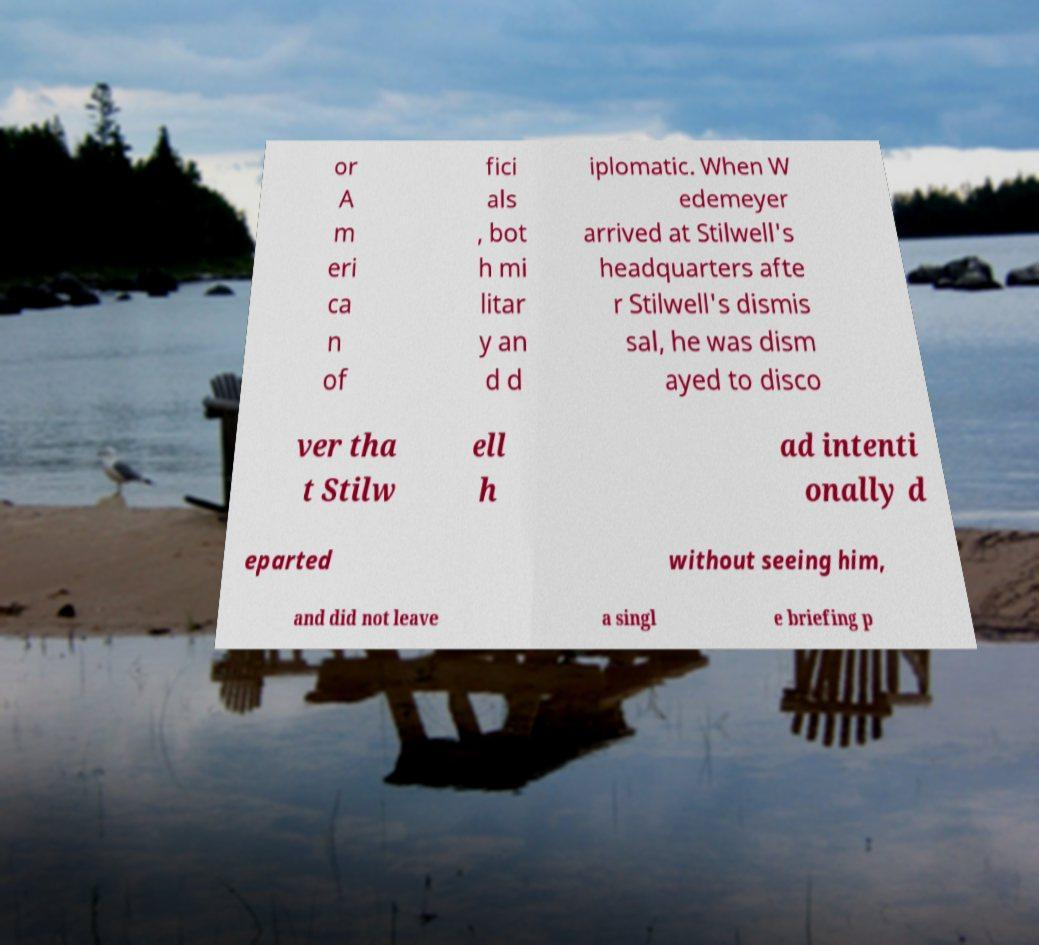I need the written content from this picture converted into text. Can you do that? or A m eri ca n of fici als , bot h mi litar y an d d iplomatic. When W edemeyer arrived at Stilwell's headquarters afte r Stilwell's dismis sal, he was dism ayed to disco ver tha t Stilw ell h ad intenti onally d eparted without seeing him, and did not leave a singl e briefing p 